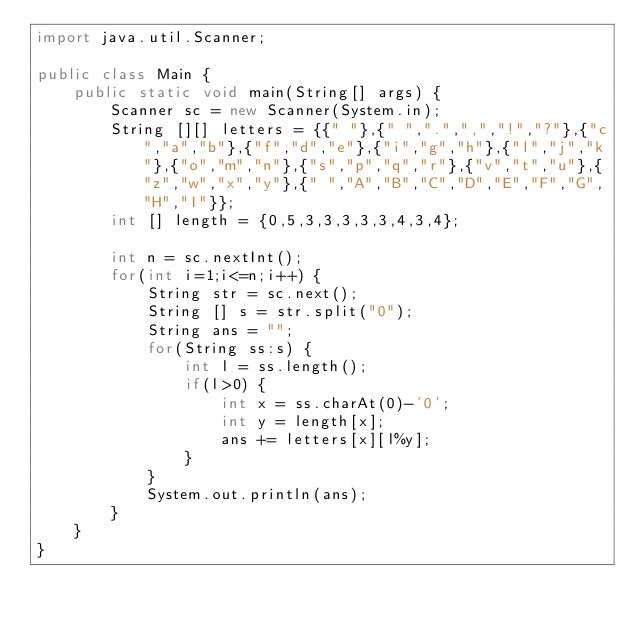Convert code to text. <code><loc_0><loc_0><loc_500><loc_500><_Java_>import java.util.Scanner;

public class Main {
    public static void main(String[] args) {
    	Scanner sc = new Scanner(System.in);
    	String [][] letters = {{" "},{" ",".",",","!","?"},{"c","a","b"},{"f","d","e"},{"i","g","h"},{"l","j","k"},{"o","m","n"},{"s","p","q","r"},{"v","t","u"},{"z","w","x","y"},{" ","A","B","C","D","E","F","G","H","I"}};
    	int [] length = {0,5,3,3,3,3,3,4,3,4};
    	
    	int n = sc.nextInt();
    	for(int i=1;i<=n;i++) {
    		String str = sc.next();
    		String [] s = str.split("0");
    		String ans = "";
    		for(String ss:s) {
    			int l = ss.length();
    			if(l>0) {
    				int x = ss.charAt(0)-'0';
        			int y = length[x];
        			ans += letters[x][l%y];
    			}
    		}
    		System.out.println(ans);
        }
    }
}
</code> 